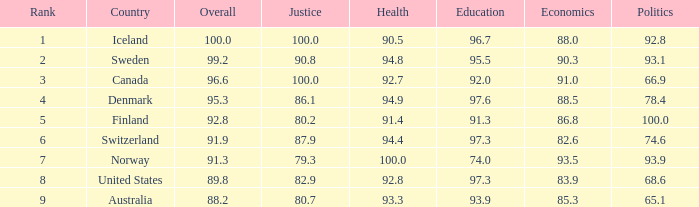What's the rank for iceland 1.0. 